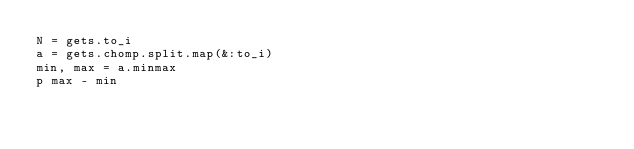Convert code to text. <code><loc_0><loc_0><loc_500><loc_500><_Ruby_>N = gets.to_i
a = gets.chomp.split.map(&:to_i)
min, max = a.minmax
p max - min</code> 